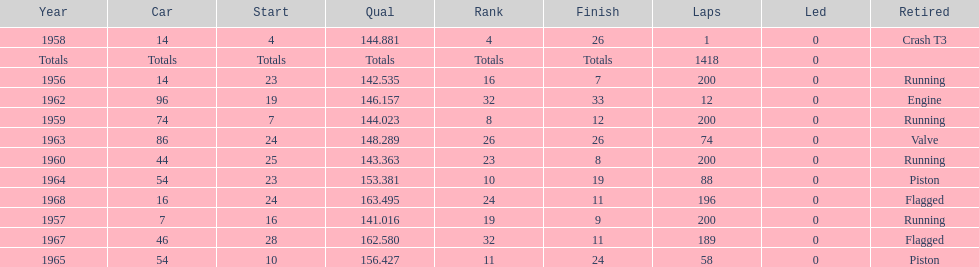Indicate the number of moments he concluded over 10th rank. 3. 